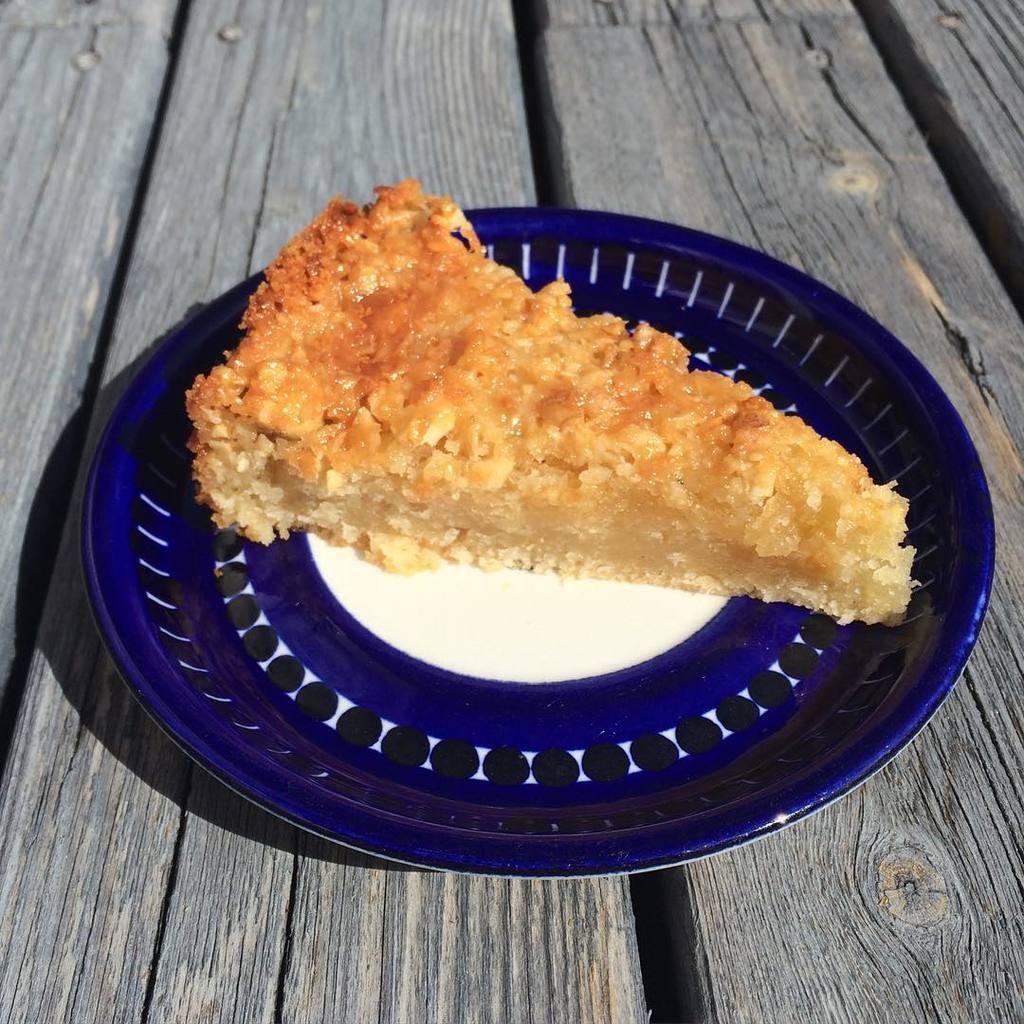Could you give a brief overview of what you see in this image? In this image there is a food item on a plate on a table. 